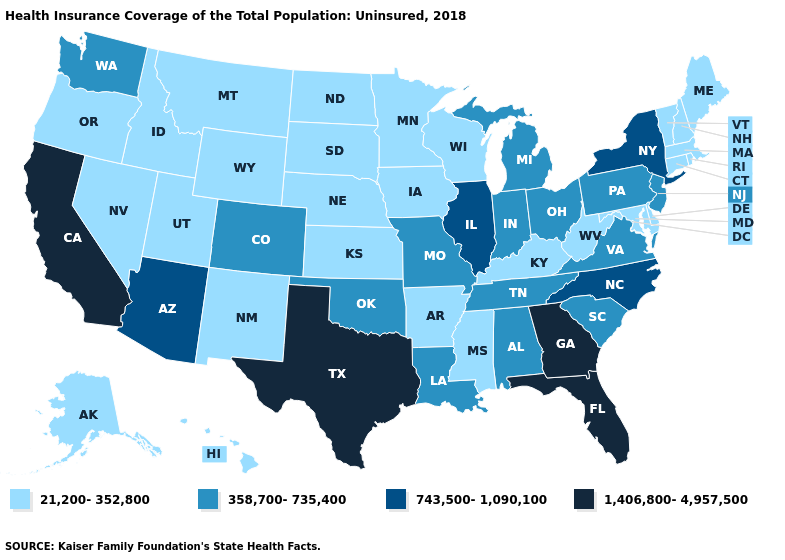What is the value of Ohio?
Short answer required. 358,700-735,400. Name the states that have a value in the range 358,700-735,400?
Write a very short answer. Alabama, Colorado, Indiana, Louisiana, Michigan, Missouri, New Jersey, Ohio, Oklahoma, Pennsylvania, South Carolina, Tennessee, Virginia, Washington. Among the states that border Oklahoma , does Colorado have the highest value?
Keep it brief. No. What is the value of West Virginia?
Give a very brief answer. 21,200-352,800. Does Wyoming have the lowest value in the USA?
Concise answer only. Yes. Name the states that have a value in the range 743,500-1,090,100?
Quick response, please. Arizona, Illinois, New York, North Carolina. How many symbols are there in the legend?
Keep it brief. 4. What is the value of Idaho?
Keep it brief. 21,200-352,800. Does Minnesota have the same value as Illinois?
Short answer required. No. Does Georgia have the highest value in the South?
Short answer required. Yes. Does the first symbol in the legend represent the smallest category?
Concise answer only. Yes. Does Alabama have the lowest value in the South?
Concise answer only. No. What is the highest value in states that border California?
Give a very brief answer. 743,500-1,090,100. Does South Dakota have the lowest value in the MidWest?
Be succinct. Yes. 